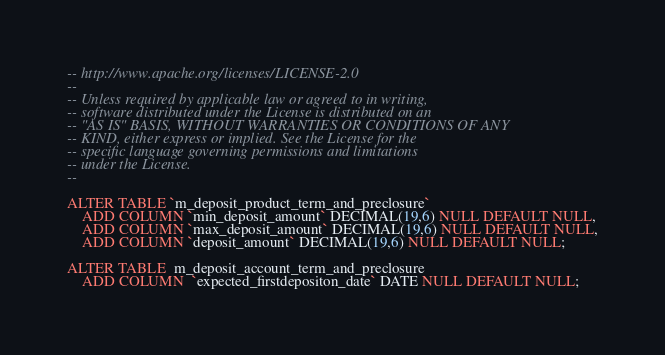Convert code to text. <code><loc_0><loc_0><loc_500><loc_500><_SQL_>-- http://www.apache.org/licenses/LICENSE-2.0
--
-- Unless required by applicable law or agreed to in writing,
-- software distributed under the License is distributed on an
-- "AS IS" BASIS, WITHOUT WARRANTIES OR CONDITIONS OF ANY
-- KIND, either express or implied. See the License for the
-- specific language governing permissions and limitations
-- under the License.
--

ALTER TABLE `m_deposit_product_term_and_preclosure`
	ADD COLUMN `min_deposit_amount` DECIMAL(19,6) NULL DEFAULT NULL,
	ADD COLUMN `max_deposit_amount` DECIMAL(19,6) NULL DEFAULT NULL,
	ADD COLUMN `deposit_amount` DECIMAL(19,6) NULL DEFAULT NULL;

ALTER TABLE  m_deposit_account_term_and_preclosure
	ADD COLUMN  `expected_firstdepositon_date` DATE NULL DEFAULT NULL;</code> 